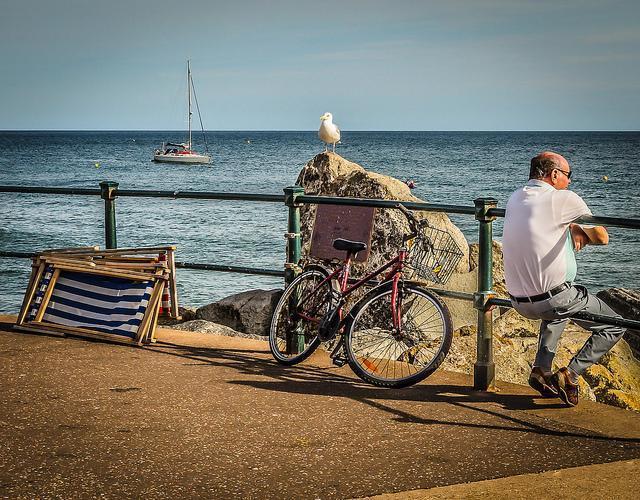How many boats are in the water?
Give a very brief answer. 1. 